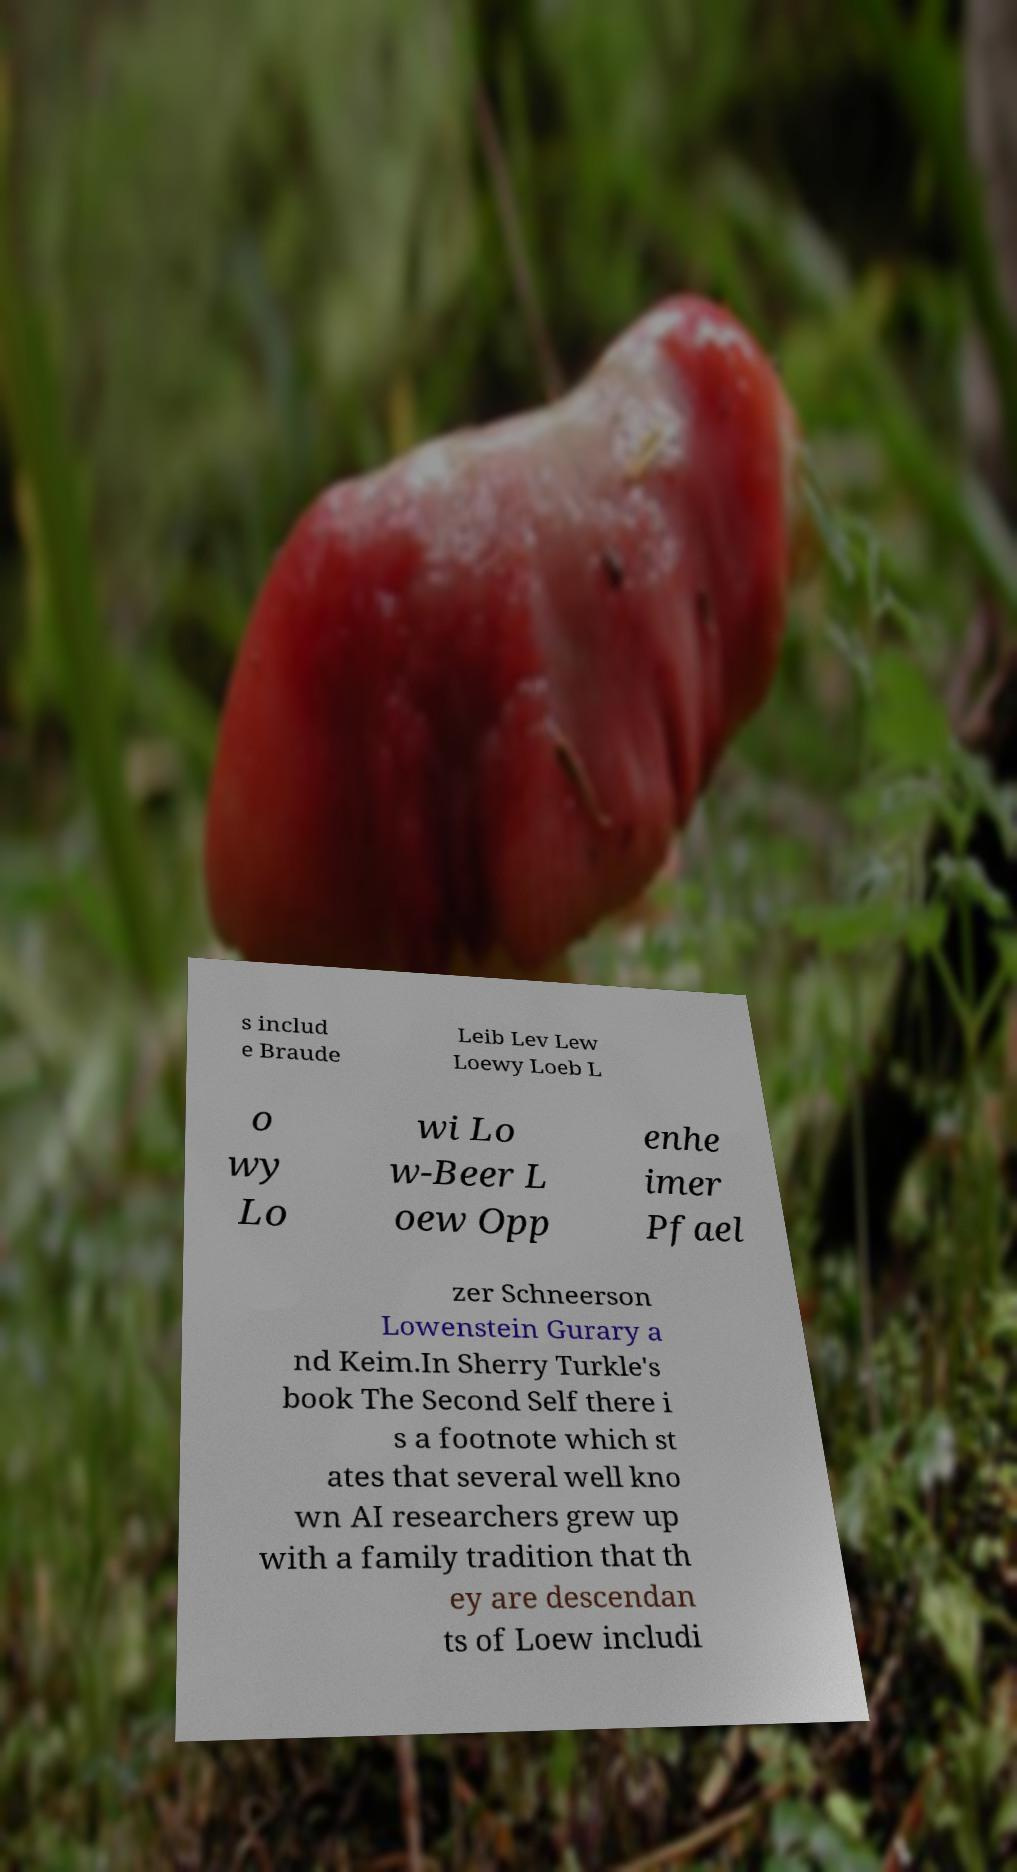I need the written content from this picture converted into text. Can you do that? s includ e Braude Leib Lev Lew Loewy Loeb L o wy Lo wi Lo w-Beer L oew Opp enhe imer Pfael zer Schneerson Lowenstein Gurary a nd Keim.In Sherry Turkle's book The Second Self there i s a footnote which st ates that several well kno wn AI researchers grew up with a family tradition that th ey are descendan ts of Loew includi 